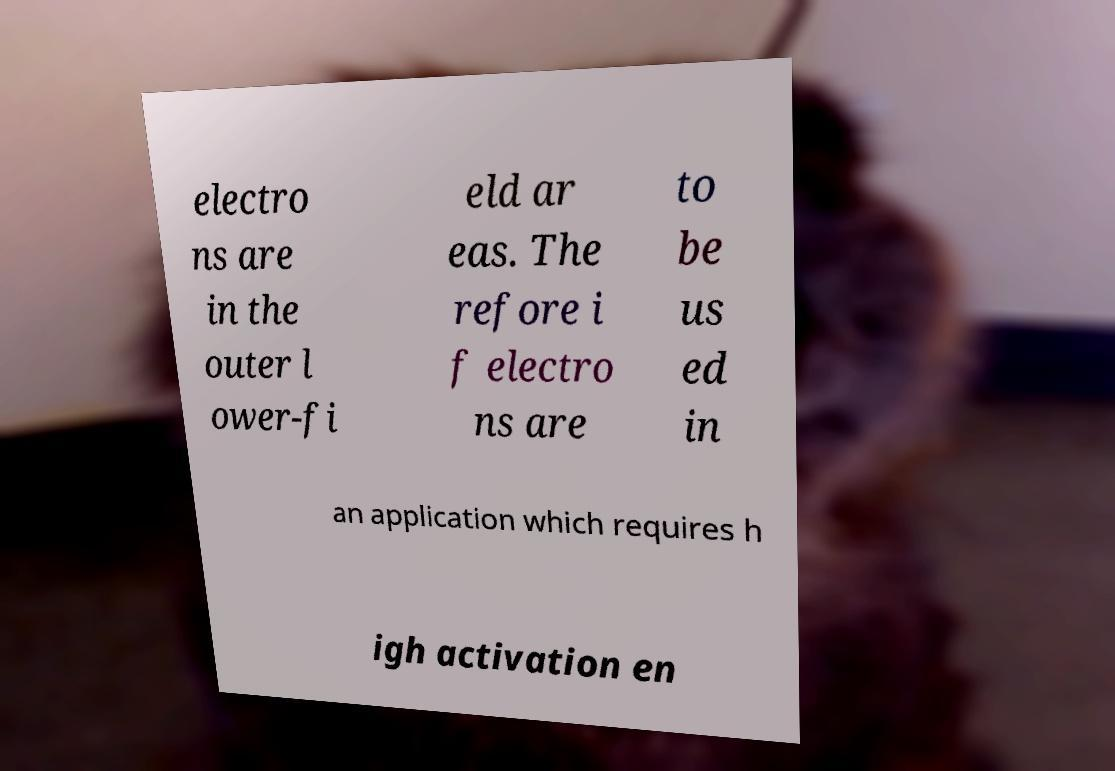Please identify and transcribe the text found in this image. electro ns are in the outer l ower-fi eld ar eas. The refore i f electro ns are to be us ed in an application which requires h igh activation en 